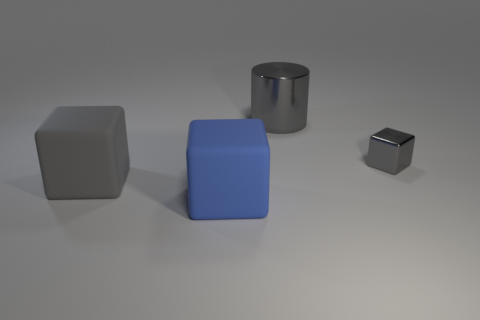Does the metal thing that is on the right side of the large shiny cylinder have the same shape as the big gray metal object?
Provide a short and direct response. No. There is a cube left of the blue block; is there a big blue rubber block behind it?
Give a very brief answer. No. How many gray rubber objects are there?
Offer a terse response. 1. What is the color of the object that is both left of the gray metal cylinder and behind the big blue rubber thing?
Your answer should be very brief. Gray. The other rubber thing that is the same shape as the gray rubber thing is what size?
Make the answer very short. Large. How many gray cylinders are the same size as the gray metallic cube?
Offer a very short reply. 0. What material is the cylinder?
Your answer should be compact. Metal. Are there any objects behind the gray metallic cylinder?
Offer a very short reply. No. What is the size of the gray object that is made of the same material as the big gray cylinder?
Give a very brief answer. Small. How many other metallic cylinders are the same color as the cylinder?
Offer a very short reply. 0. 